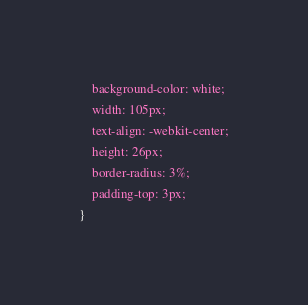<code> <loc_0><loc_0><loc_500><loc_500><_CSS_>    background-color: white;
    width: 105px;
    text-align: -webkit-center;
    height: 26px;
    border-radius: 3%;
    padding-top: 3px;
}</code> 